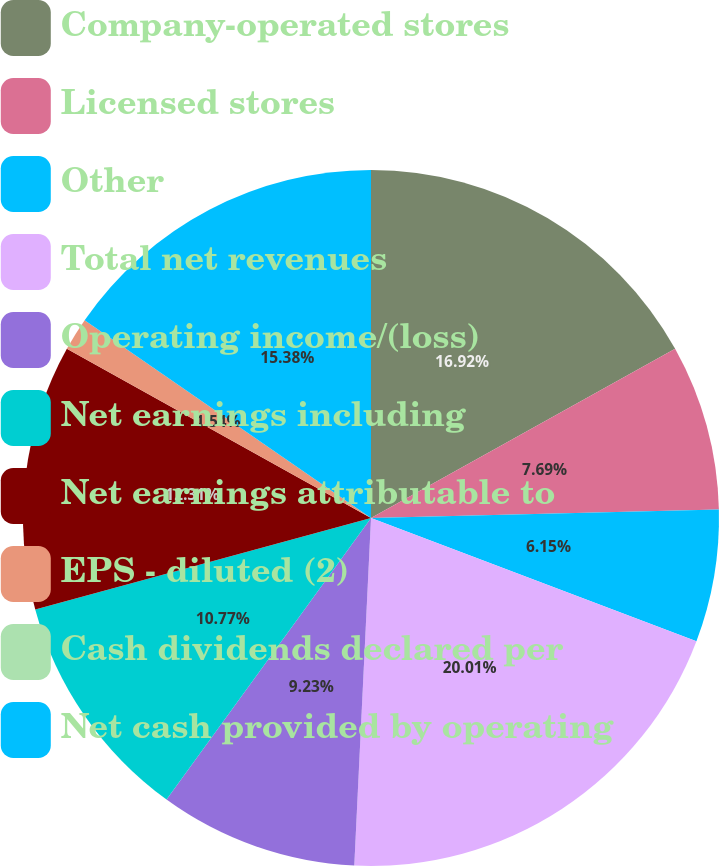Convert chart. <chart><loc_0><loc_0><loc_500><loc_500><pie_chart><fcel>Company-operated stores<fcel>Licensed stores<fcel>Other<fcel>Total net revenues<fcel>Operating income/(loss)<fcel>Net earnings including<fcel>Net earnings attributable to<fcel>EPS - diluted (2)<fcel>Cash dividends declared per<fcel>Net cash provided by operating<nl><fcel>16.92%<fcel>7.69%<fcel>6.15%<fcel>20.0%<fcel>9.23%<fcel>10.77%<fcel>12.31%<fcel>1.54%<fcel>0.0%<fcel>15.38%<nl></chart> 